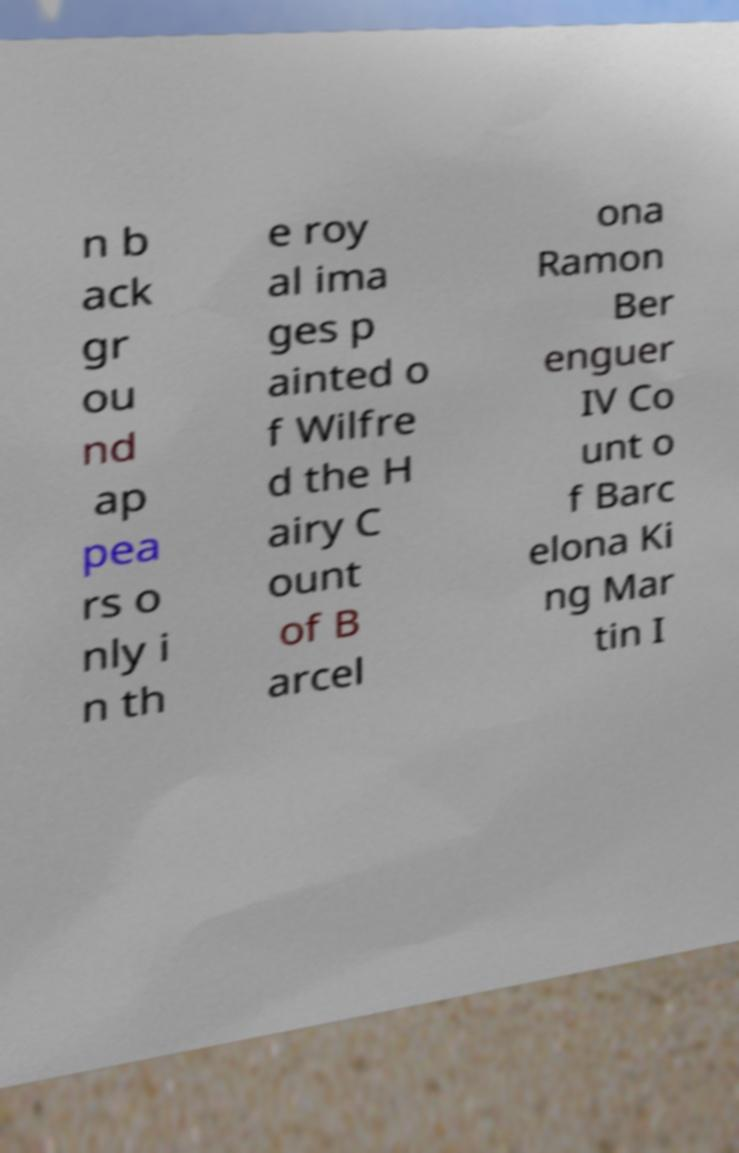Could you assist in decoding the text presented in this image and type it out clearly? n b ack gr ou nd ap pea rs o nly i n th e roy al ima ges p ainted o f Wilfre d the H airy C ount of B arcel ona Ramon Ber enguer IV Co unt o f Barc elona Ki ng Mar tin I 